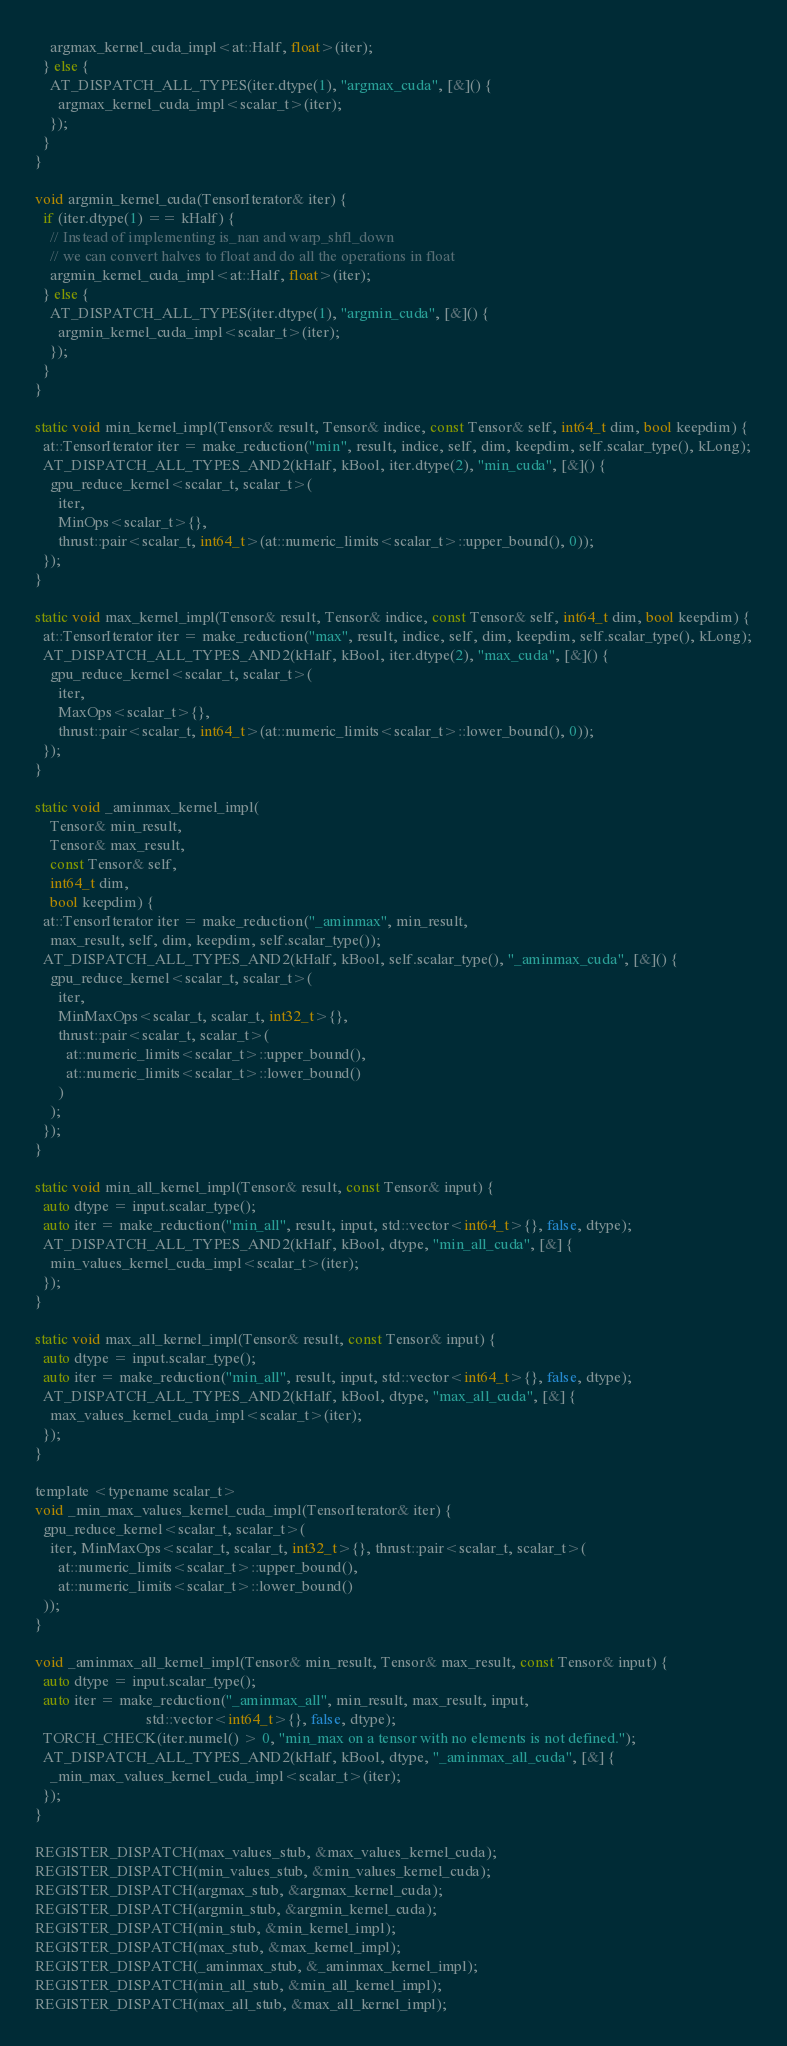<code> <loc_0><loc_0><loc_500><loc_500><_Cuda_>    argmax_kernel_cuda_impl<at::Half, float>(iter);
  } else {
    AT_DISPATCH_ALL_TYPES(iter.dtype(1), "argmax_cuda", [&]() {
      argmax_kernel_cuda_impl<scalar_t>(iter);
    });
  }
}

void argmin_kernel_cuda(TensorIterator& iter) {
  if (iter.dtype(1) == kHalf) {
    // Instead of implementing is_nan and warp_shfl_down
    // we can convert halves to float and do all the operations in float
    argmin_kernel_cuda_impl<at::Half, float>(iter);
  } else {
    AT_DISPATCH_ALL_TYPES(iter.dtype(1), "argmin_cuda", [&]() {
      argmin_kernel_cuda_impl<scalar_t>(iter);
    });
  }
}

static void min_kernel_impl(Tensor& result, Tensor& indice, const Tensor& self, int64_t dim, bool keepdim) {
  at::TensorIterator iter = make_reduction("min", result, indice, self, dim, keepdim, self.scalar_type(), kLong);
  AT_DISPATCH_ALL_TYPES_AND2(kHalf, kBool, iter.dtype(2), "min_cuda", [&]() {
    gpu_reduce_kernel<scalar_t, scalar_t>(
      iter,
      MinOps<scalar_t>{},
      thrust::pair<scalar_t, int64_t>(at::numeric_limits<scalar_t>::upper_bound(), 0));
  });
}

static void max_kernel_impl(Tensor& result, Tensor& indice, const Tensor& self, int64_t dim, bool keepdim) {
  at::TensorIterator iter = make_reduction("max", result, indice, self, dim, keepdim, self.scalar_type(), kLong);
  AT_DISPATCH_ALL_TYPES_AND2(kHalf, kBool, iter.dtype(2), "max_cuda", [&]() {
    gpu_reduce_kernel<scalar_t, scalar_t>(
      iter,
      MaxOps<scalar_t>{},
      thrust::pair<scalar_t, int64_t>(at::numeric_limits<scalar_t>::lower_bound(), 0));
  });
}

static void _aminmax_kernel_impl(
    Tensor& min_result,
    Tensor& max_result,
    const Tensor& self,
    int64_t dim,
    bool keepdim) {
  at::TensorIterator iter = make_reduction("_aminmax", min_result, 
    max_result, self, dim, keepdim, self.scalar_type());
  AT_DISPATCH_ALL_TYPES_AND2(kHalf, kBool, self.scalar_type(), "_aminmax_cuda", [&]() {
    gpu_reduce_kernel<scalar_t, scalar_t>(
      iter,
      MinMaxOps<scalar_t, scalar_t, int32_t>{},
      thrust::pair<scalar_t, scalar_t>(
        at::numeric_limits<scalar_t>::upper_bound(), 
        at::numeric_limits<scalar_t>::lower_bound()
      )
    );
  });
}

static void min_all_kernel_impl(Tensor& result, const Tensor& input) {
  auto dtype = input.scalar_type();
  auto iter = make_reduction("min_all", result, input, std::vector<int64_t>{}, false, dtype);
  AT_DISPATCH_ALL_TYPES_AND2(kHalf, kBool, dtype, "min_all_cuda", [&] {
    min_values_kernel_cuda_impl<scalar_t>(iter);
  });
}

static void max_all_kernel_impl(Tensor& result, const Tensor& input) {
  auto dtype = input.scalar_type();
  auto iter = make_reduction("min_all", result, input, std::vector<int64_t>{}, false, dtype);
  AT_DISPATCH_ALL_TYPES_AND2(kHalf, kBool, dtype, "max_all_cuda", [&] {
    max_values_kernel_cuda_impl<scalar_t>(iter);
  });
}

template <typename scalar_t>
void _min_max_values_kernel_cuda_impl(TensorIterator& iter) {
  gpu_reduce_kernel<scalar_t, scalar_t>(
    iter, MinMaxOps<scalar_t, scalar_t, int32_t>{}, thrust::pair<scalar_t, scalar_t>(
      at::numeric_limits<scalar_t>::upper_bound(),
      at::numeric_limits<scalar_t>::lower_bound()
  ));
}

void _aminmax_all_kernel_impl(Tensor& min_result, Tensor& max_result, const Tensor& input) {
  auto dtype = input.scalar_type();
  auto iter = make_reduction("_aminmax_all", min_result, max_result, input,
                             std::vector<int64_t>{}, false, dtype);
  TORCH_CHECK(iter.numel() > 0, "min_max on a tensor with no elements is not defined.");
  AT_DISPATCH_ALL_TYPES_AND2(kHalf, kBool, dtype, "_aminmax_all_cuda", [&] {
    _min_max_values_kernel_cuda_impl<scalar_t>(iter);
  });
}

REGISTER_DISPATCH(max_values_stub, &max_values_kernel_cuda);
REGISTER_DISPATCH(min_values_stub, &min_values_kernel_cuda);
REGISTER_DISPATCH(argmax_stub, &argmax_kernel_cuda);
REGISTER_DISPATCH(argmin_stub, &argmin_kernel_cuda);
REGISTER_DISPATCH(min_stub, &min_kernel_impl);
REGISTER_DISPATCH(max_stub, &max_kernel_impl);
REGISTER_DISPATCH(_aminmax_stub, &_aminmax_kernel_impl);
REGISTER_DISPATCH(min_all_stub, &min_all_kernel_impl);
REGISTER_DISPATCH(max_all_stub, &max_all_kernel_impl);</code> 